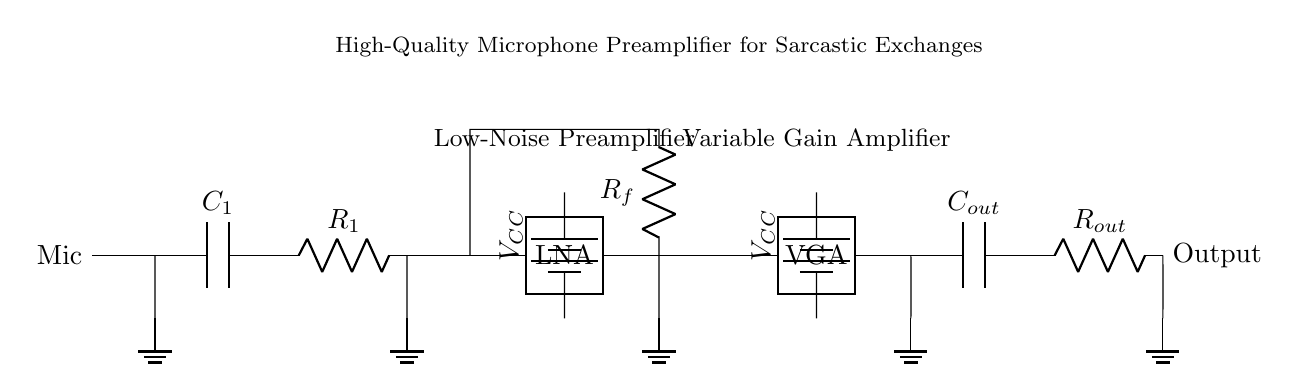What component is used to block DC voltage? In the circuit, the capacitor labeled C1 is utilized to block DC voltage while allowing AC signals to pass through. Capacitors are known for this property, making them essential in audio applications.
Answer: C1 What is the purpose of Rf? The resistor Rf forms a feedback network, which is crucial for setting the gain of the first amplifier stage. By adjusting Rf, the feedback ratio changes, influencing the overall amplification of the input signal.
Answer: Rf How many amplifier stages are in this circuit? The circuit includes two amplifier stages: a low-noise preamplifier and a variable gain amplifier. This design allows for initial amplification followed by adjustable gain.
Answer: Two What type of amplifier is used first in the circuit? The first amplifier stage is a low-noise amplifier (LNA), which is specifically designed to amplify weak signals without adding significant noise. This is vital for capturing nuanced audio, such as sarcasm.
Answer: Low-noise amplifier What is the voltage supply for the second amplifier? The voltage supply for the second amplifier stage, indicated with a battery symbol, is VCC, as shown next to the variable gain amplifier in the schematic. This power supply is essential for the circuit to function.
Answer: VCC In which stage is the gain adjustable? The variable gain amplifier stage allows for gain adjustment. This is critical in applications like microphone recordings where varying levels of sarcasm may require different levels of amplification for clarity.
Answer: Variable gain amplifier What is the final output component in the circuit? The final output component is Rout, which is placed after the output capacitor Cout. This resistor helps to define the output signal's connection to the next stage or load in the circuit.
Answer: Rout 